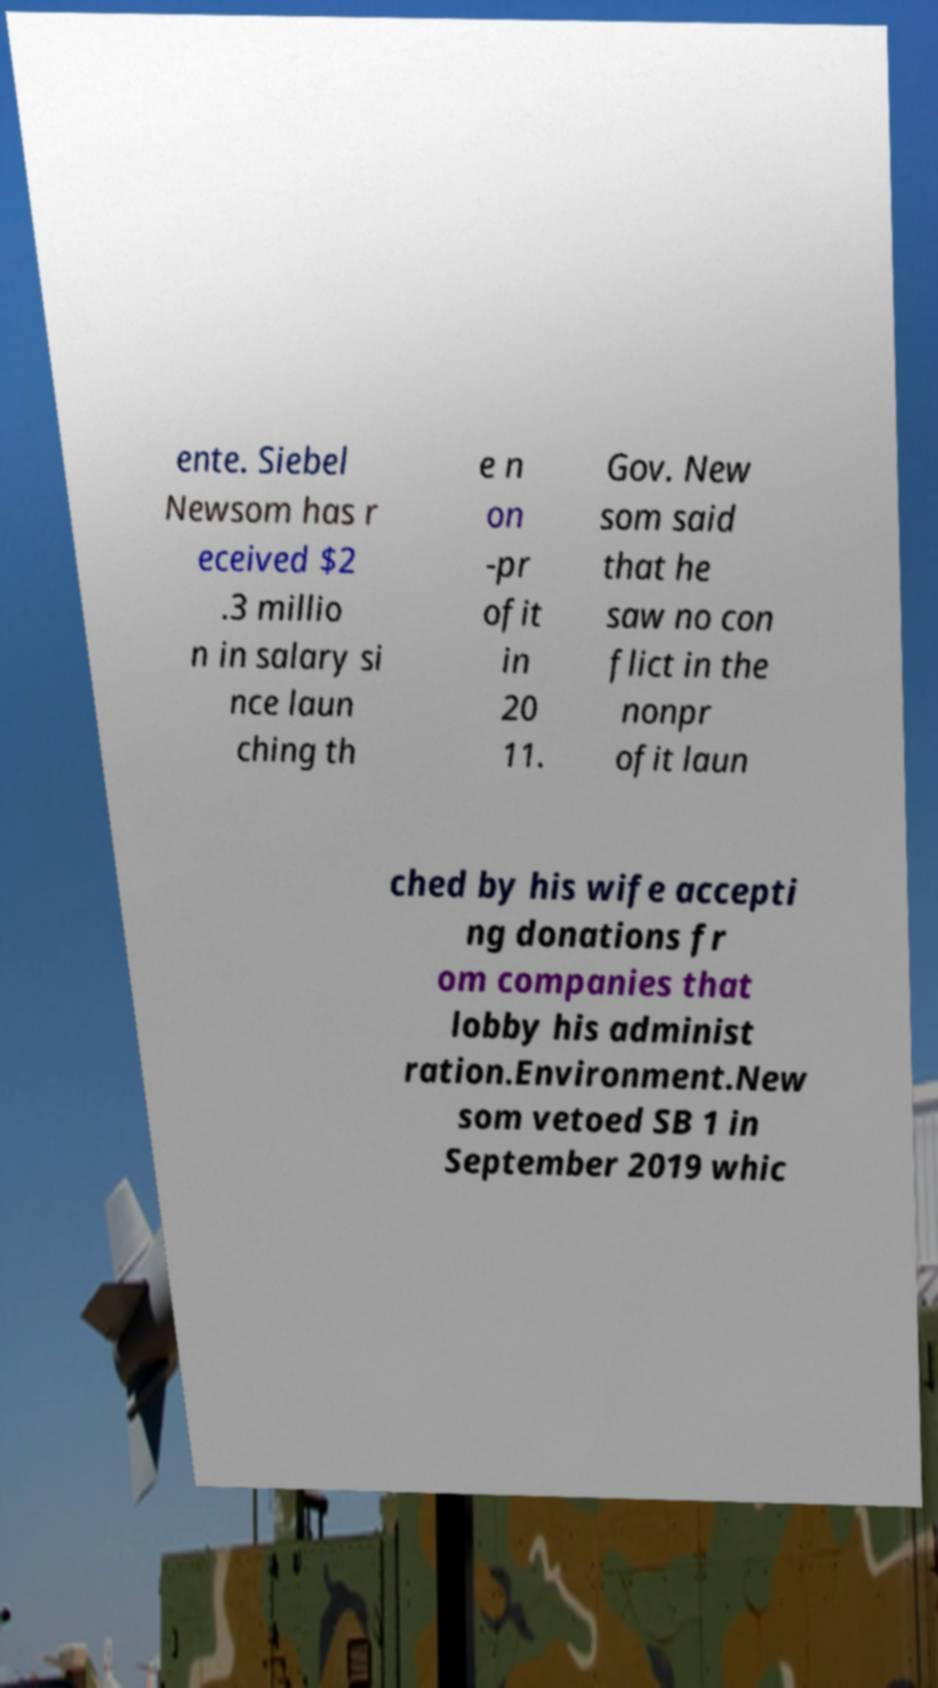Can you read and provide the text displayed in the image?This photo seems to have some interesting text. Can you extract and type it out for me? ente. Siebel Newsom has r eceived $2 .3 millio n in salary si nce laun ching th e n on -pr ofit in 20 11. Gov. New som said that he saw no con flict in the nonpr ofit laun ched by his wife accepti ng donations fr om companies that lobby his administ ration.Environment.New som vetoed SB 1 in September 2019 whic 